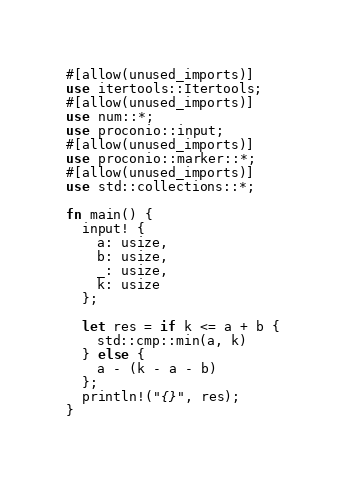Convert code to text. <code><loc_0><loc_0><loc_500><loc_500><_Rust_>#[allow(unused_imports)]
use itertools::Itertools;
#[allow(unused_imports)]
use num::*;
use proconio::input;
#[allow(unused_imports)]
use proconio::marker::*;
#[allow(unused_imports)]
use std::collections::*;

fn main() {
  input! {
    a: usize,
    b: usize,
    _: usize,
    k: usize
  };

  let res = if k <= a + b {
    std::cmp::min(a, k)
  } else {
    a - (k - a - b)
  };
  println!("{}", res);
}
</code> 